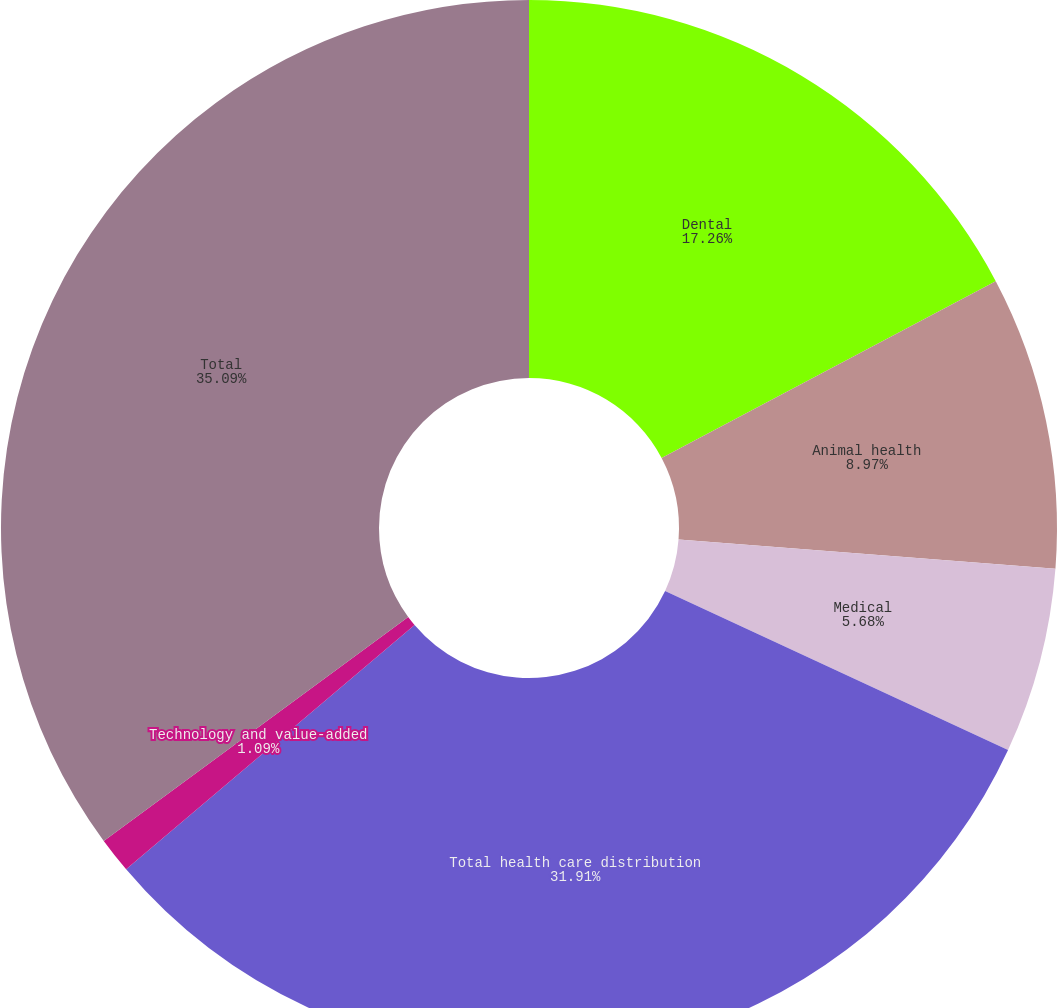Convert chart. <chart><loc_0><loc_0><loc_500><loc_500><pie_chart><fcel>Dental<fcel>Animal health<fcel>Medical<fcel>Total health care distribution<fcel>Technology and value-added<fcel>Total<nl><fcel>17.26%<fcel>8.97%<fcel>5.68%<fcel>31.91%<fcel>1.09%<fcel>35.1%<nl></chart> 